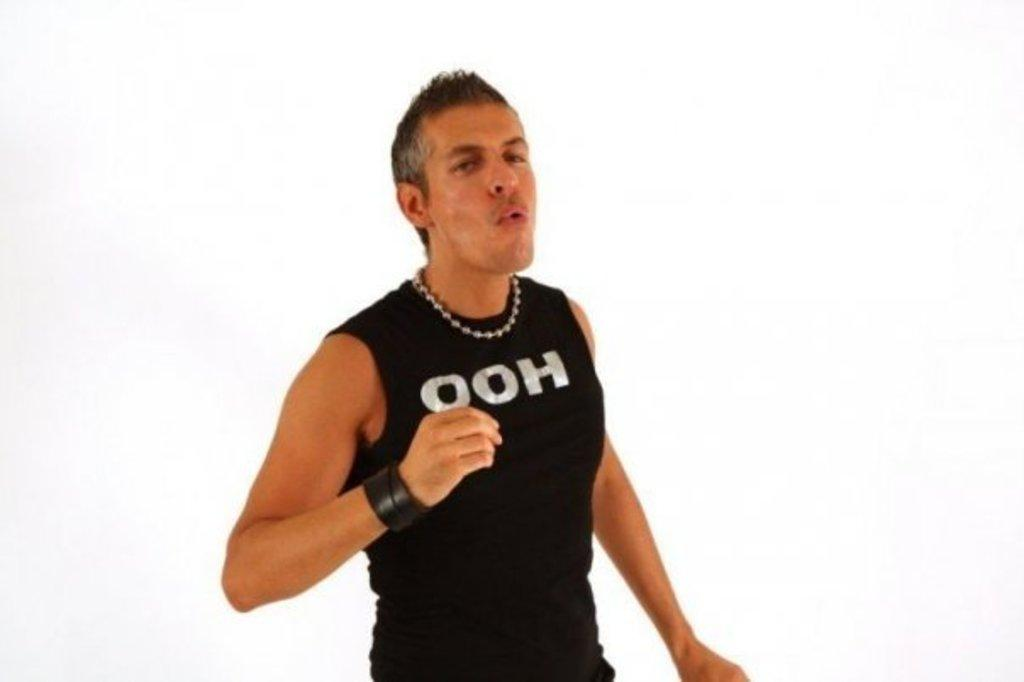Who or what is the main subject in the front of the image? There is a person in the front of the image. What color is the background of the image? The background of the image is white. What type of dress is the volcano wearing in the image? There is no volcano present in the image, and therefore no dress or any other clothing can be observed. 